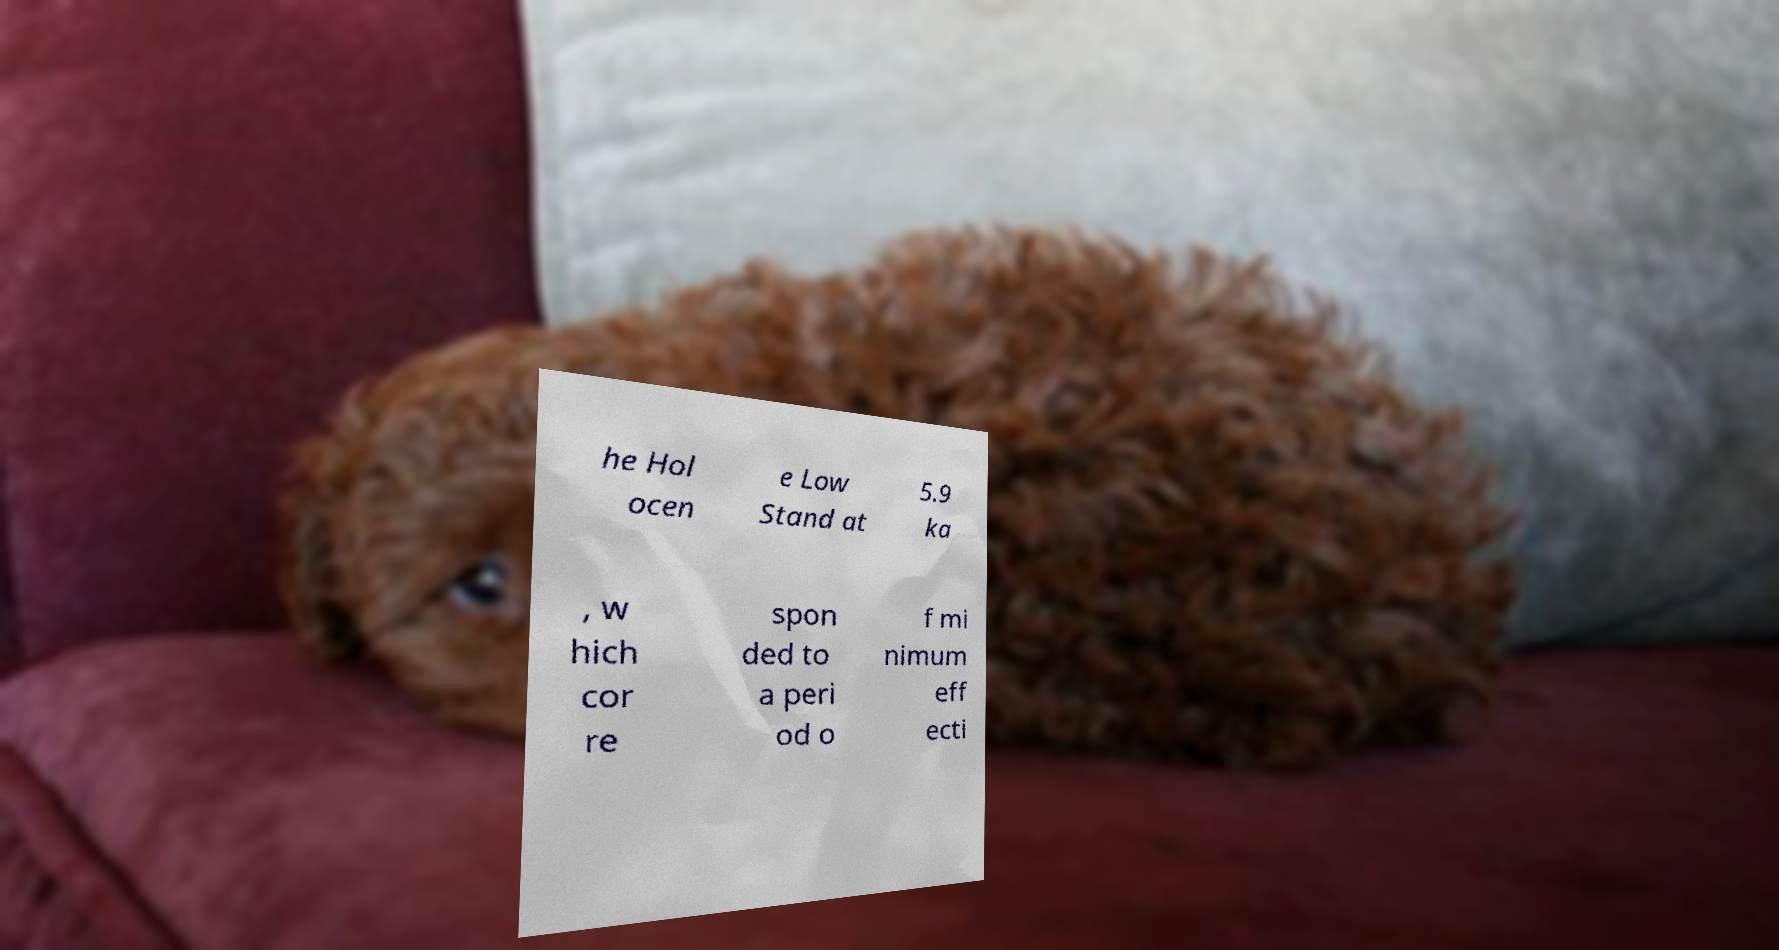What messages or text are displayed in this image? I need them in a readable, typed format. he Hol ocen e Low Stand at 5.9 ka , w hich cor re spon ded to a peri od o f mi nimum eff ecti 